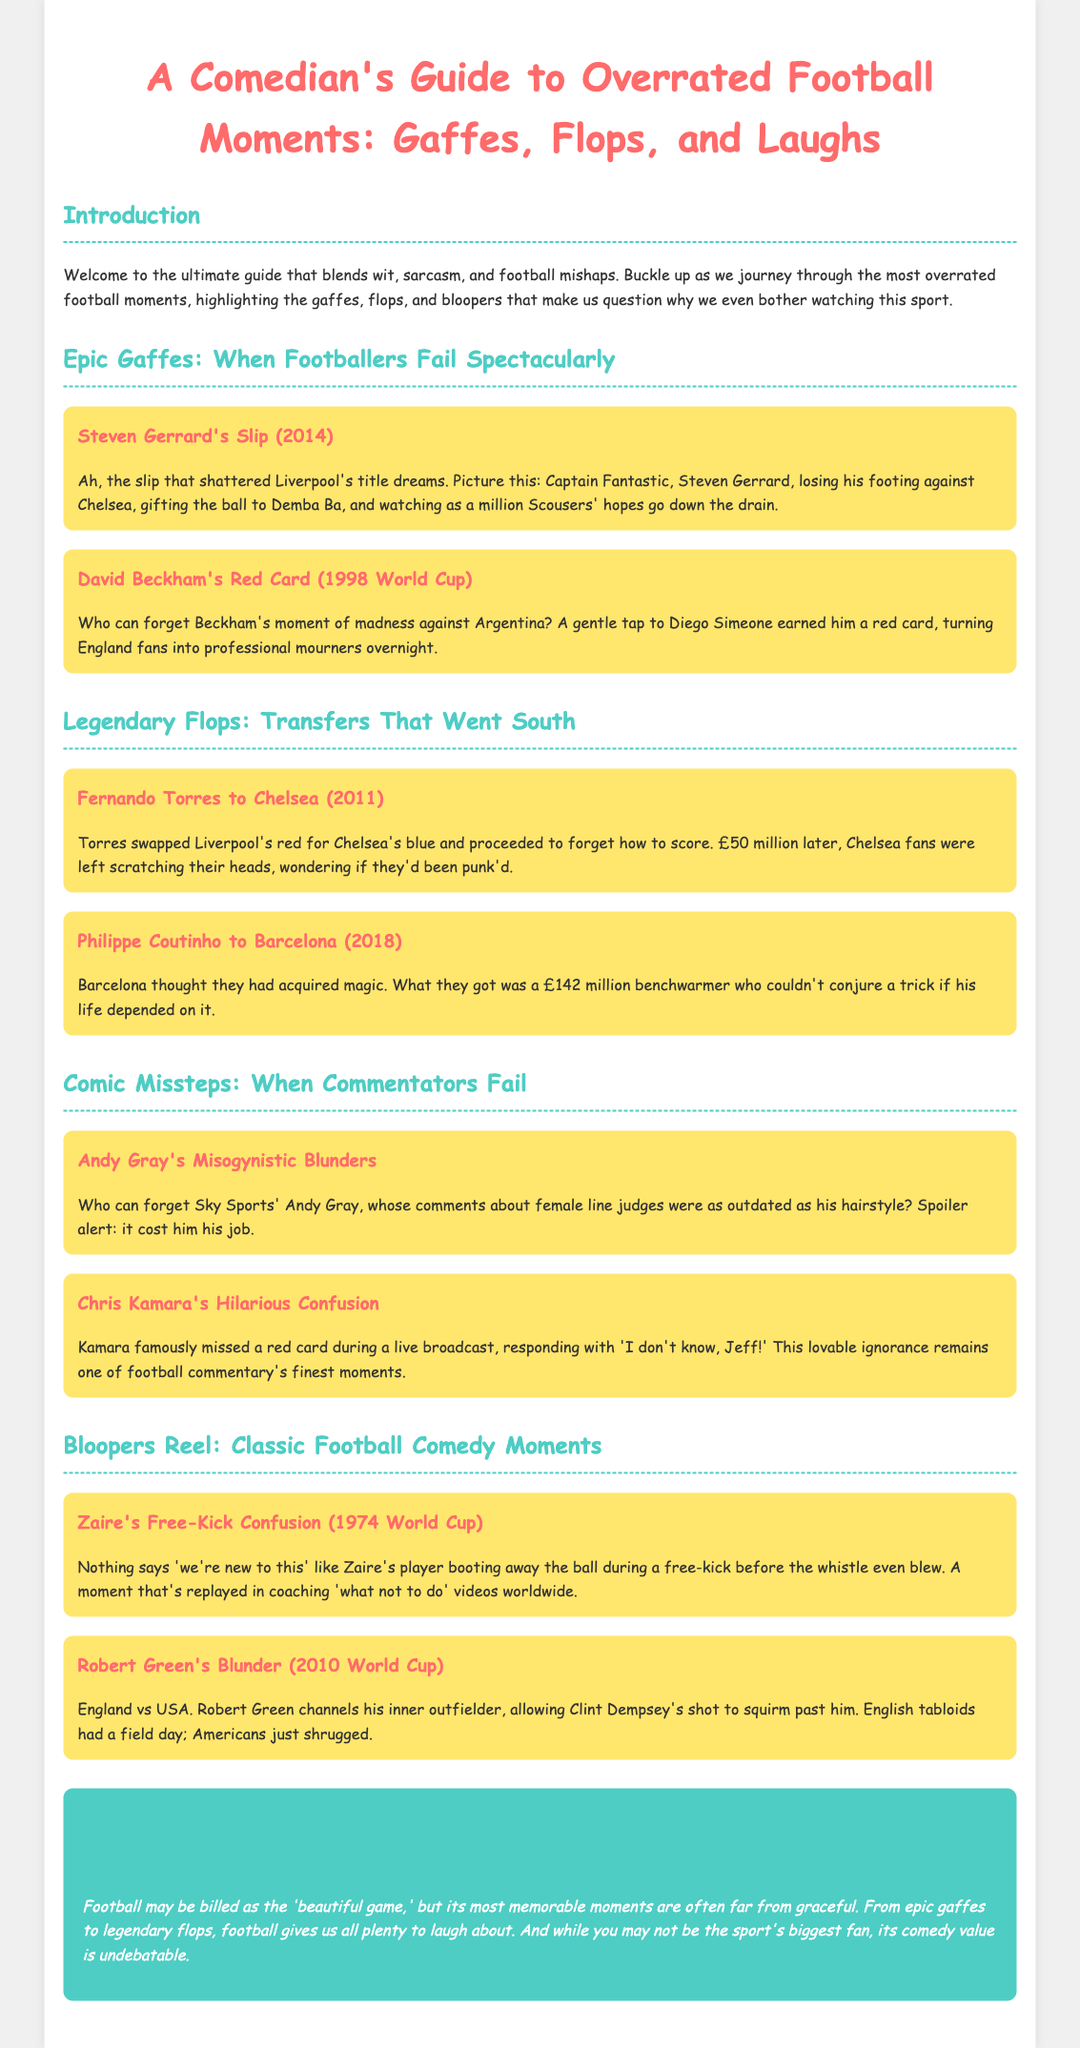what is the title of the document? The title is found in the header section of the document, stating "A Comedian's Guide to Overrated Football Moments: Gaffes, Flops, and Laughs."
Answer: A Comedian's Guide to Overrated Football Moments: Gaffes, Flops, and Laughs who made a slip in 2014? This information is discussed in the section about Epic Gaffes, referring to Steven Gerrard's incident in 2014.
Answer: Steven Gerrard how much did Barcelona pay for Philippe Coutinho? The document states that Barcelona acquired Coutinho for £142 million, mentioned in the Legendary Flops section.
Answer: £142 million which commentator confused viewers by missing a red card? This is highlighted under the Comic Missteps section, referring to Chris Kamara's amusing mix-up during a live broadcast.
Answer: Chris Kamara what year did Robert Green's blunder occur? The blunder is identified as happening during the 2010 World Cup in the Bloopers Reel section.
Answer: 2010 how many major sections are in the document? The document is divided into five main sections, including Introduction, Epic Gaffes, Legendary Flops, Comic Missteps, and Bloopers Reel.
Answer: Five what color theme is used in the document's header? The header uses a color theme of pink for the title, contrasting with the rest of the document's design elements.
Answer: Pink what is the overall theme of the document? The document combines humor and sarcasm while discussing overrated moments in football.
Answer: Humor and sarcasm 